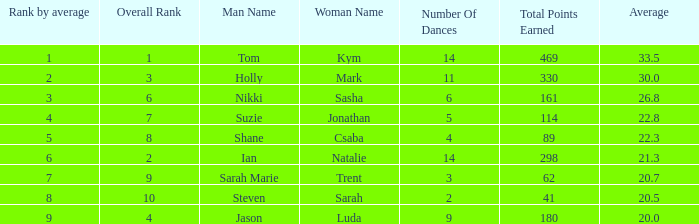What was the name of the couple if the number of dances is 6? Nikki & Sasha. 